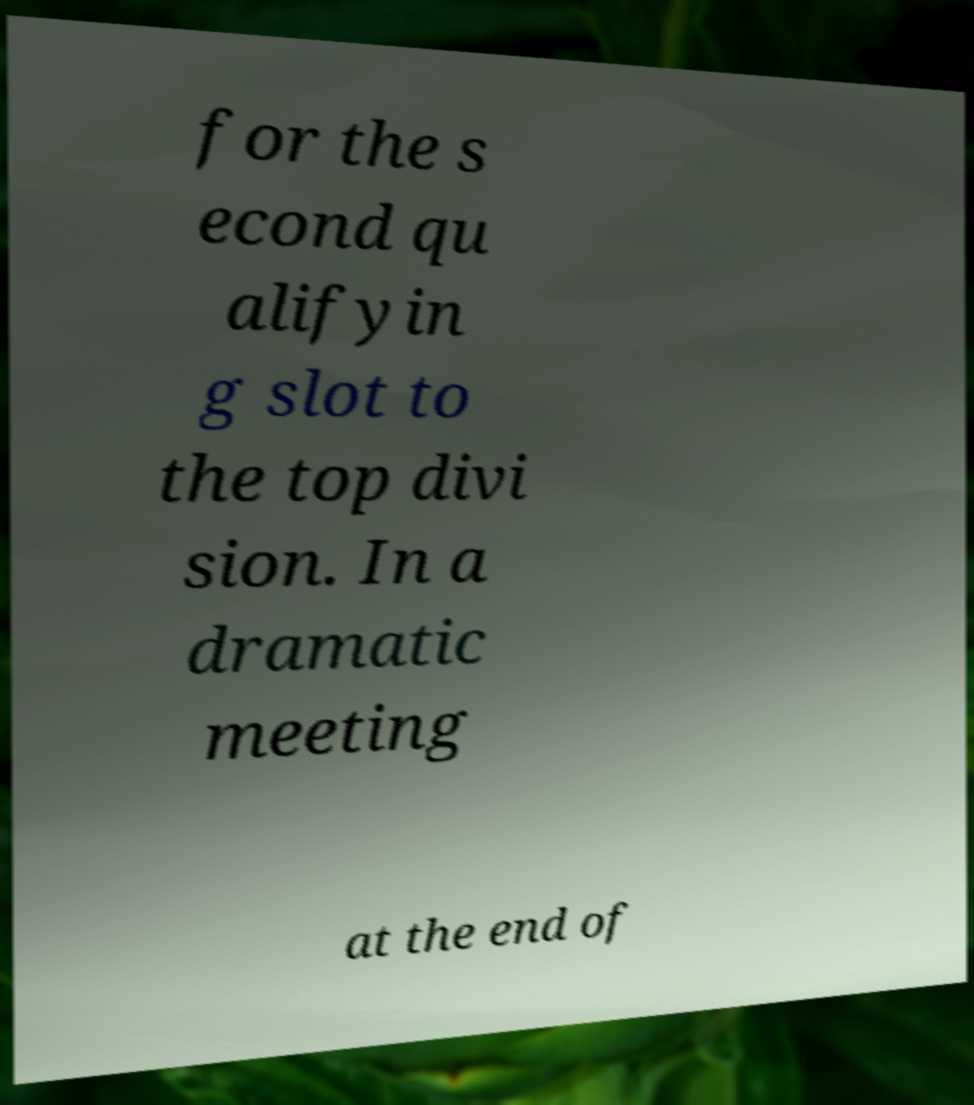For documentation purposes, I need the text within this image transcribed. Could you provide that? for the s econd qu alifyin g slot to the top divi sion. In a dramatic meeting at the end of 